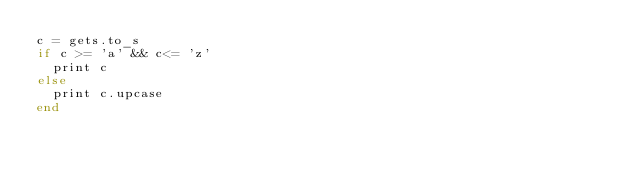<code> <loc_0><loc_0><loc_500><loc_500><_Ruby_>c = gets.to_s
if c >= 'a' && c<= 'z'
  print c
else
  print c.upcase
end</code> 